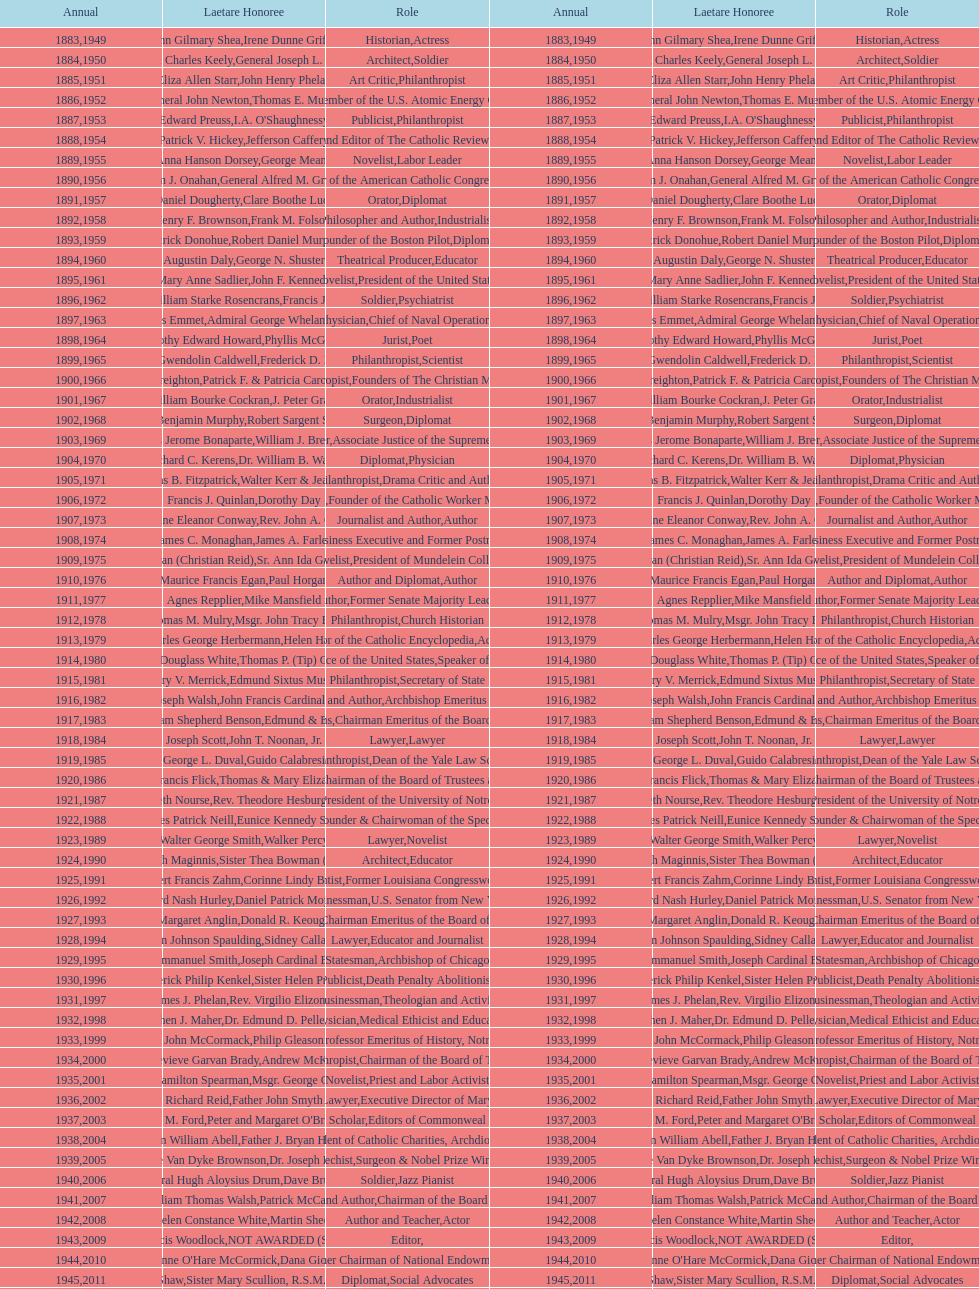What are the total number of times soldier is listed as the position on this chart? 4. 